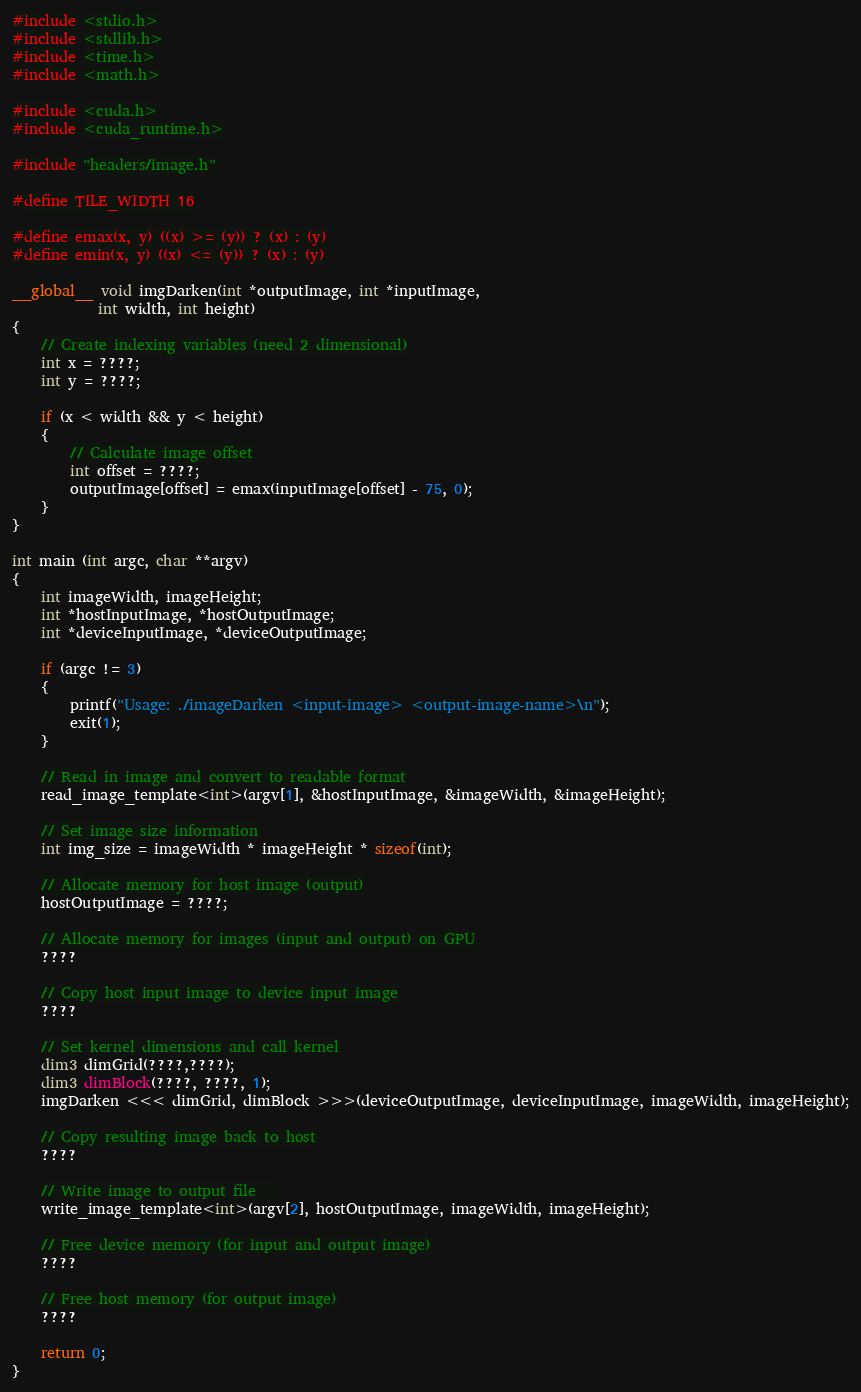<code> <loc_0><loc_0><loc_500><loc_500><_Cuda_>#include <stdio.h>
#include <stdlib.h>
#include <time.h>
#include <math.h>

#include <cuda.h>
#include <cuda_runtime.h>

#include "headers/image.h"

#define TILE_WIDTH 16

#define emax(x, y) ((x) >= (y)) ? (x) : (y)
#define emin(x, y) ((x) <= (y)) ? (x) : (y)

__global__ void imgDarken(int *outputImage, int *inputImage,
			int width, int height)
{
	// Create indexing variables (need 2 dimensional)
	int x = ????;
	int y = ????;

	if (x < width && y < height)
	{
		// Calculate image offset
		int offset = ????;
		outputImage[offset] = emax(inputImage[offset] - 75, 0);
	}
}

int main (int argc, char **argv)
{
	int imageWidth, imageHeight;
	int *hostInputImage, *hostOutputImage;
	int *deviceInputImage, *deviceOutputImage;

	if (argc != 3)
	{
		printf("Usage: ./imageDarken <input-image> <output-image-name>\n");
		exit(1);
	}

	// Read in image and convert to readable format
	read_image_template<int>(argv[1], &hostInputImage, &imageWidth, &imageHeight);

	// Set image size information
	int img_size = imageWidth * imageHeight * sizeof(int);

	// Allocate memory for host image (output)
	hostOutputImage = ????;

	// Allocate memory for images (input and output) on GPU
	????
	
	// Copy host input image to device input image
	????

	// Set kernel dimensions and call kernel
	dim3 dimGrid(????,????);
	dim3 dimBlock(????, ????, 1);
	imgDarken <<< dimGrid, dimBlock >>>(deviceOutputImage, deviceInputImage, imageWidth, imageHeight);

	// Copy resulting image back to host
	????

	// Write image to output file	
	write_image_template<int>(argv[2], hostOutputImage, imageWidth, imageHeight);

	// Free device memory (for input and output image)
	????
	
	// Free host memory (for output image)
	????

	return 0;
}
</code> 